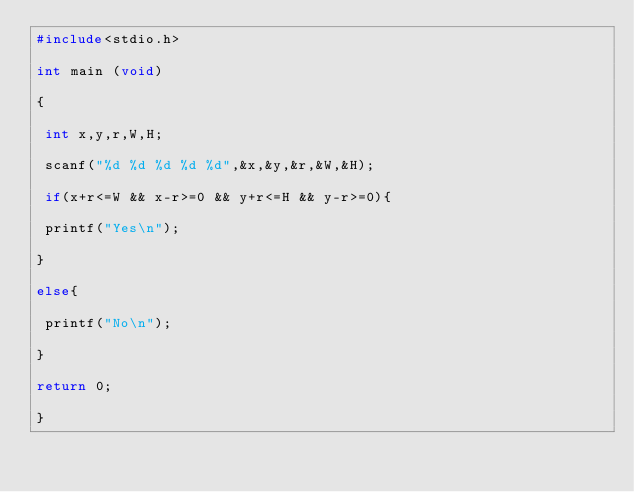<code> <loc_0><loc_0><loc_500><loc_500><_C_>#include<stdio.h>

int main (void)

{

 int x,y,r,W,H;

 scanf("%d %d %d %d %d",&x,&y,&r,&W,&H);

 if(x+r<=W && x-r>=0 && y+r<=H && y-r>=0){

 printf("Yes\n");

}

else{

 printf("No\n");

}

return 0;

}</code> 